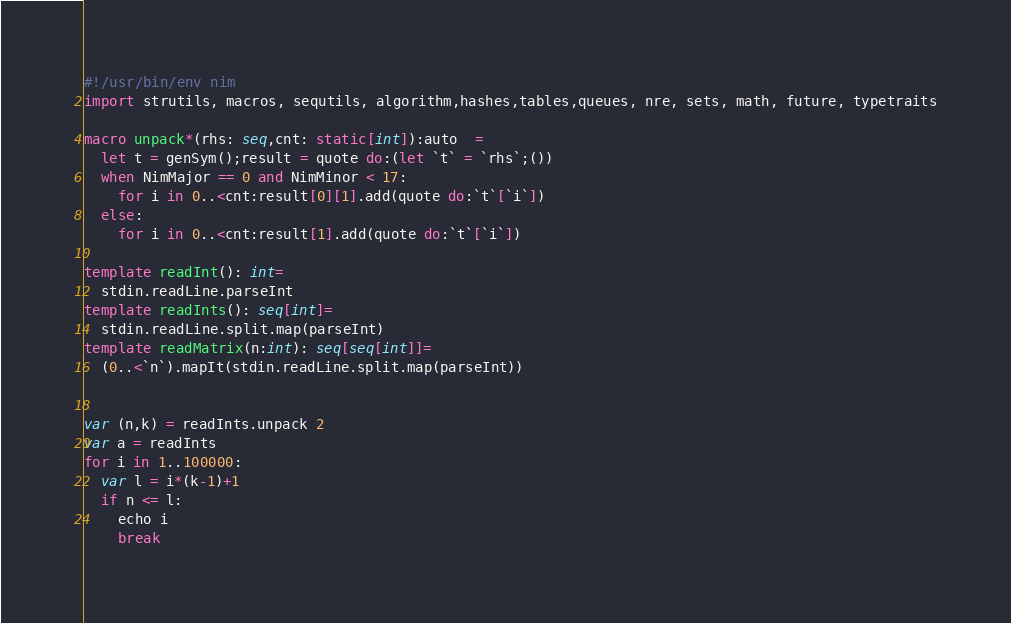Convert code to text. <code><loc_0><loc_0><loc_500><loc_500><_Nim_>#!/usr/bin/env nim
import strutils, macros, sequtils, algorithm,hashes,tables,queues, nre, sets, math, future, typetraits

macro unpack*(rhs: seq,cnt: static[int]):auto  =
  let t = genSym();result = quote do:(let `t` = `rhs`;())
  when NimMajor == 0 and NimMinor < 17:
    for i in 0..<cnt:result[0][1].add(quote do:`t`[`i`])
  else:
    for i in 0..<cnt:result[1].add(quote do:`t`[`i`])

template readInt(): int=
  stdin.readLine.parseInt
template readInts(): seq[int]=
  stdin.readLine.split.map(parseInt)
template readMatrix(n:int): seq[seq[int]]=
  (0..<`n`).mapIt(stdin.readLine.split.map(parseInt))


var (n,k) = readInts.unpack 2
var a = readInts
for i in 1..100000:
  var l = i*(k-1)+1
  if n <= l:
    echo i
    break
</code> 